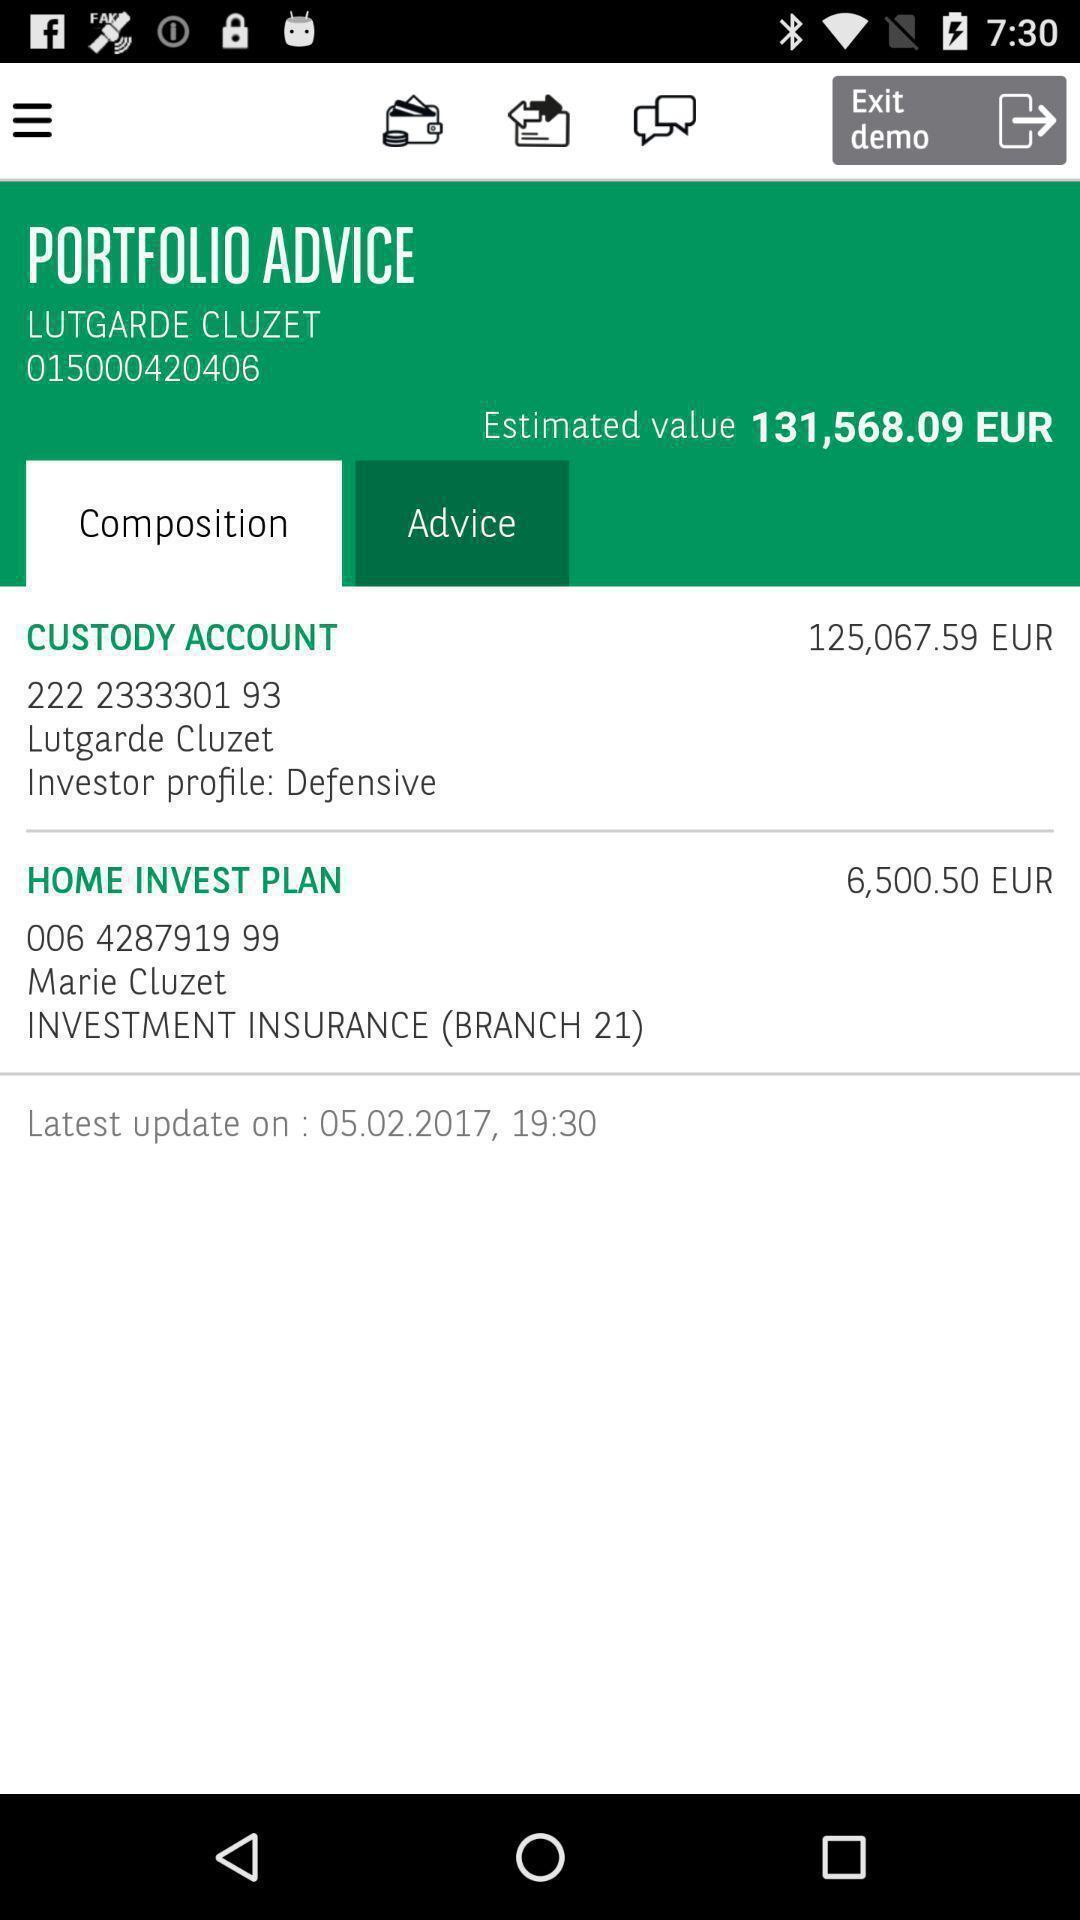Describe the content in this image. Screen shows multiple options in an financial application. 